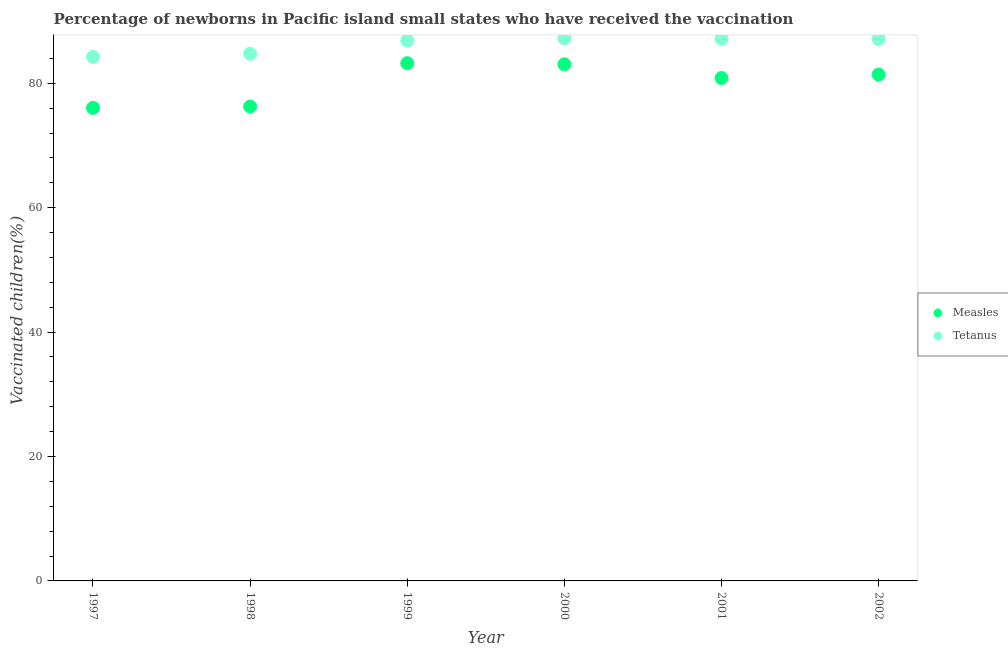What is the percentage of newborns who received vaccination for measles in 1997?
Provide a short and direct response. 76.05. Across all years, what is the maximum percentage of newborns who received vaccination for measles?
Your response must be concise. 83.22. Across all years, what is the minimum percentage of newborns who received vaccination for tetanus?
Your answer should be very brief. 84.24. What is the total percentage of newborns who received vaccination for tetanus in the graph?
Give a very brief answer. 517.33. What is the difference between the percentage of newborns who received vaccination for measles in 2001 and that in 2002?
Offer a terse response. -0.55. What is the difference between the percentage of newborns who received vaccination for tetanus in 2002 and the percentage of newborns who received vaccination for measles in 1998?
Ensure brevity in your answer.  10.85. What is the average percentage of newborns who received vaccination for tetanus per year?
Provide a short and direct response. 86.22. In the year 2000, what is the difference between the percentage of newborns who received vaccination for tetanus and percentage of newborns who received vaccination for measles?
Your answer should be very brief. 4.17. What is the ratio of the percentage of newborns who received vaccination for tetanus in 1999 to that in 2000?
Ensure brevity in your answer.  1. What is the difference between the highest and the second highest percentage of newborns who received vaccination for tetanus?
Give a very brief answer. 0.06. What is the difference between the highest and the lowest percentage of newborns who received vaccination for tetanus?
Keep it short and to the point. 2.97. In how many years, is the percentage of newborns who received vaccination for measles greater than the average percentage of newborns who received vaccination for measles taken over all years?
Provide a short and direct response. 4. Is the sum of the percentage of newborns who received vaccination for measles in 2001 and 2002 greater than the maximum percentage of newborns who received vaccination for tetanus across all years?
Offer a terse response. Yes. How many years are there in the graph?
Offer a terse response. 6. What is the difference between two consecutive major ticks on the Y-axis?
Offer a terse response. 20. Are the values on the major ticks of Y-axis written in scientific E-notation?
Provide a short and direct response. No. Does the graph contain any zero values?
Ensure brevity in your answer.  No. Does the graph contain grids?
Your response must be concise. No. Where does the legend appear in the graph?
Your answer should be very brief. Center right. How many legend labels are there?
Your response must be concise. 2. How are the legend labels stacked?
Your answer should be very brief. Vertical. What is the title of the graph?
Keep it short and to the point. Percentage of newborns in Pacific island small states who have received the vaccination. What is the label or title of the X-axis?
Your answer should be compact. Year. What is the label or title of the Y-axis?
Make the answer very short. Vaccinated children(%)
. What is the Vaccinated children(%)
 of Measles in 1997?
Give a very brief answer. 76.05. What is the Vaccinated children(%)
 of Tetanus in 1997?
Your answer should be very brief. 84.24. What is the Vaccinated children(%)
 of Measles in 1998?
Offer a terse response. 76.25. What is the Vaccinated children(%)
 in Tetanus in 1998?
Make the answer very short. 84.74. What is the Vaccinated children(%)
 in Measles in 1999?
Keep it short and to the point. 83.22. What is the Vaccinated children(%)
 in Tetanus in 1999?
Ensure brevity in your answer.  86.87. What is the Vaccinated children(%)
 of Measles in 2000?
Offer a terse response. 83.05. What is the Vaccinated children(%)
 of Tetanus in 2000?
Offer a very short reply. 87.22. What is the Vaccinated children(%)
 of Measles in 2001?
Offer a terse response. 80.84. What is the Vaccinated children(%)
 of Tetanus in 2001?
Provide a short and direct response. 87.16. What is the Vaccinated children(%)
 in Measles in 2002?
Make the answer very short. 81.39. What is the Vaccinated children(%)
 of Tetanus in 2002?
Your response must be concise. 87.1. Across all years, what is the maximum Vaccinated children(%)
 of Measles?
Provide a succinct answer. 83.22. Across all years, what is the maximum Vaccinated children(%)
 of Tetanus?
Keep it short and to the point. 87.22. Across all years, what is the minimum Vaccinated children(%)
 in Measles?
Your answer should be very brief. 76.05. Across all years, what is the minimum Vaccinated children(%)
 of Tetanus?
Offer a terse response. 84.24. What is the total Vaccinated children(%)
 in Measles in the graph?
Make the answer very short. 480.8. What is the total Vaccinated children(%)
 of Tetanus in the graph?
Your answer should be very brief. 517.33. What is the difference between the Vaccinated children(%)
 in Measles in 1997 and that in 1998?
Give a very brief answer. -0.21. What is the difference between the Vaccinated children(%)
 of Tetanus in 1997 and that in 1998?
Provide a short and direct response. -0.5. What is the difference between the Vaccinated children(%)
 of Measles in 1997 and that in 1999?
Provide a short and direct response. -7.17. What is the difference between the Vaccinated children(%)
 in Tetanus in 1997 and that in 1999?
Ensure brevity in your answer.  -2.63. What is the difference between the Vaccinated children(%)
 in Measles in 1997 and that in 2000?
Offer a very short reply. -7. What is the difference between the Vaccinated children(%)
 of Tetanus in 1997 and that in 2000?
Provide a short and direct response. -2.97. What is the difference between the Vaccinated children(%)
 in Measles in 1997 and that in 2001?
Provide a succinct answer. -4.8. What is the difference between the Vaccinated children(%)
 in Tetanus in 1997 and that in 2001?
Your answer should be very brief. -2.92. What is the difference between the Vaccinated children(%)
 of Measles in 1997 and that in 2002?
Offer a very short reply. -5.34. What is the difference between the Vaccinated children(%)
 of Tetanus in 1997 and that in 2002?
Provide a short and direct response. -2.86. What is the difference between the Vaccinated children(%)
 of Measles in 1998 and that in 1999?
Provide a succinct answer. -6.96. What is the difference between the Vaccinated children(%)
 of Tetanus in 1998 and that in 1999?
Keep it short and to the point. -2.13. What is the difference between the Vaccinated children(%)
 in Measles in 1998 and that in 2000?
Provide a short and direct response. -6.79. What is the difference between the Vaccinated children(%)
 in Tetanus in 1998 and that in 2000?
Your answer should be very brief. -2.47. What is the difference between the Vaccinated children(%)
 in Measles in 1998 and that in 2001?
Provide a succinct answer. -4.59. What is the difference between the Vaccinated children(%)
 in Tetanus in 1998 and that in 2001?
Your answer should be compact. -2.42. What is the difference between the Vaccinated children(%)
 in Measles in 1998 and that in 2002?
Provide a short and direct response. -5.14. What is the difference between the Vaccinated children(%)
 of Tetanus in 1998 and that in 2002?
Provide a succinct answer. -2.36. What is the difference between the Vaccinated children(%)
 in Measles in 1999 and that in 2000?
Keep it short and to the point. 0.17. What is the difference between the Vaccinated children(%)
 in Tetanus in 1999 and that in 2000?
Offer a terse response. -0.35. What is the difference between the Vaccinated children(%)
 in Measles in 1999 and that in 2001?
Make the answer very short. 2.38. What is the difference between the Vaccinated children(%)
 in Tetanus in 1999 and that in 2001?
Give a very brief answer. -0.29. What is the difference between the Vaccinated children(%)
 of Measles in 1999 and that in 2002?
Ensure brevity in your answer.  1.83. What is the difference between the Vaccinated children(%)
 in Tetanus in 1999 and that in 2002?
Make the answer very short. -0.23. What is the difference between the Vaccinated children(%)
 of Measles in 2000 and that in 2001?
Make the answer very short. 2.21. What is the difference between the Vaccinated children(%)
 of Tetanus in 2000 and that in 2001?
Your answer should be compact. 0.06. What is the difference between the Vaccinated children(%)
 in Measles in 2000 and that in 2002?
Offer a very short reply. 1.66. What is the difference between the Vaccinated children(%)
 in Tetanus in 2000 and that in 2002?
Your answer should be compact. 0.11. What is the difference between the Vaccinated children(%)
 of Measles in 2001 and that in 2002?
Offer a terse response. -0.55. What is the difference between the Vaccinated children(%)
 in Tetanus in 2001 and that in 2002?
Offer a very short reply. 0.06. What is the difference between the Vaccinated children(%)
 in Measles in 1997 and the Vaccinated children(%)
 in Tetanus in 1998?
Provide a succinct answer. -8.7. What is the difference between the Vaccinated children(%)
 of Measles in 1997 and the Vaccinated children(%)
 of Tetanus in 1999?
Ensure brevity in your answer.  -10.83. What is the difference between the Vaccinated children(%)
 in Measles in 1997 and the Vaccinated children(%)
 in Tetanus in 2000?
Ensure brevity in your answer.  -11.17. What is the difference between the Vaccinated children(%)
 of Measles in 1997 and the Vaccinated children(%)
 of Tetanus in 2001?
Keep it short and to the point. -11.11. What is the difference between the Vaccinated children(%)
 of Measles in 1997 and the Vaccinated children(%)
 of Tetanus in 2002?
Give a very brief answer. -11.06. What is the difference between the Vaccinated children(%)
 of Measles in 1998 and the Vaccinated children(%)
 of Tetanus in 1999?
Your answer should be very brief. -10.62. What is the difference between the Vaccinated children(%)
 of Measles in 1998 and the Vaccinated children(%)
 of Tetanus in 2000?
Provide a short and direct response. -10.96. What is the difference between the Vaccinated children(%)
 of Measles in 1998 and the Vaccinated children(%)
 of Tetanus in 2001?
Keep it short and to the point. -10.91. What is the difference between the Vaccinated children(%)
 of Measles in 1998 and the Vaccinated children(%)
 of Tetanus in 2002?
Make the answer very short. -10.85. What is the difference between the Vaccinated children(%)
 in Measles in 1999 and the Vaccinated children(%)
 in Tetanus in 2000?
Provide a succinct answer. -4. What is the difference between the Vaccinated children(%)
 in Measles in 1999 and the Vaccinated children(%)
 in Tetanus in 2001?
Provide a short and direct response. -3.94. What is the difference between the Vaccinated children(%)
 of Measles in 1999 and the Vaccinated children(%)
 of Tetanus in 2002?
Your response must be concise. -3.88. What is the difference between the Vaccinated children(%)
 in Measles in 2000 and the Vaccinated children(%)
 in Tetanus in 2001?
Give a very brief answer. -4.11. What is the difference between the Vaccinated children(%)
 of Measles in 2000 and the Vaccinated children(%)
 of Tetanus in 2002?
Offer a very short reply. -4.05. What is the difference between the Vaccinated children(%)
 of Measles in 2001 and the Vaccinated children(%)
 of Tetanus in 2002?
Your answer should be very brief. -6.26. What is the average Vaccinated children(%)
 in Measles per year?
Keep it short and to the point. 80.13. What is the average Vaccinated children(%)
 in Tetanus per year?
Provide a short and direct response. 86.22. In the year 1997, what is the difference between the Vaccinated children(%)
 of Measles and Vaccinated children(%)
 of Tetanus?
Provide a short and direct response. -8.2. In the year 1998, what is the difference between the Vaccinated children(%)
 of Measles and Vaccinated children(%)
 of Tetanus?
Your response must be concise. -8.49. In the year 1999, what is the difference between the Vaccinated children(%)
 of Measles and Vaccinated children(%)
 of Tetanus?
Your answer should be very brief. -3.65. In the year 2000, what is the difference between the Vaccinated children(%)
 of Measles and Vaccinated children(%)
 of Tetanus?
Keep it short and to the point. -4.17. In the year 2001, what is the difference between the Vaccinated children(%)
 of Measles and Vaccinated children(%)
 of Tetanus?
Keep it short and to the point. -6.32. In the year 2002, what is the difference between the Vaccinated children(%)
 in Measles and Vaccinated children(%)
 in Tetanus?
Offer a terse response. -5.71. What is the ratio of the Vaccinated children(%)
 in Measles in 1997 to that in 1998?
Provide a short and direct response. 1. What is the ratio of the Vaccinated children(%)
 of Tetanus in 1997 to that in 1998?
Make the answer very short. 0.99. What is the ratio of the Vaccinated children(%)
 in Measles in 1997 to that in 1999?
Keep it short and to the point. 0.91. What is the ratio of the Vaccinated children(%)
 of Tetanus in 1997 to that in 1999?
Ensure brevity in your answer.  0.97. What is the ratio of the Vaccinated children(%)
 in Measles in 1997 to that in 2000?
Offer a very short reply. 0.92. What is the ratio of the Vaccinated children(%)
 of Tetanus in 1997 to that in 2000?
Ensure brevity in your answer.  0.97. What is the ratio of the Vaccinated children(%)
 in Measles in 1997 to that in 2001?
Offer a terse response. 0.94. What is the ratio of the Vaccinated children(%)
 in Tetanus in 1997 to that in 2001?
Your response must be concise. 0.97. What is the ratio of the Vaccinated children(%)
 of Measles in 1997 to that in 2002?
Your answer should be very brief. 0.93. What is the ratio of the Vaccinated children(%)
 of Tetanus in 1997 to that in 2002?
Offer a very short reply. 0.97. What is the ratio of the Vaccinated children(%)
 in Measles in 1998 to that in 1999?
Offer a very short reply. 0.92. What is the ratio of the Vaccinated children(%)
 in Tetanus in 1998 to that in 1999?
Give a very brief answer. 0.98. What is the ratio of the Vaccinated children(%)
 of Measles in 1998 to that in 2000?
Provide a succinct answer. 0.92. What is the ratio of the Vaccinated children(%)
 in Tetanus in 1998 to that in 2000?
Your answer should be compact. 0.97. What is the ratio of the Vaccinated children(%)
 in Measles in 1998 to that in 2001?
Give a very brief answer. 0.94. What is the ratio of the Vaccinated children(%)
 of Tetanus in 1998 to that in 2001?
Provide a short and direct response. 0.97. What is the ratio of the Vaccinated children(%)
 of Measles in 1998 to that in 2002?
Make the answer very short. 0.94. What is the ratio of the Vaccinated children(%)
 of Tetanus in 1998 to that in 2002?
Your answer should be compact. 0.97. What is the ratio of the Vaccinated children(%)
 in Measles in 1999 to that in 2000?
Keep it short and to the point. 1. What is the ratio of the Vaccinated children(%)
 of Measles in 1999 to that in 2001?
Ensure brevity in your answer.  1.03. What is the ratio of the Vaccinated children(%)
 of Measles in 1999 to that in 2002?
Ensure brevity in your answer.  1.02. What is the ratio of the Vaccinated children(%)
 of Tetanus in 1999 to that in 2002?
Offer a terse response. 1. What is the ratio of the Vaccinated children(%)
 in Measles in 2000 to that in 2001?
Keep it short and to the point. 1.03. What is the ratio of the Vaccinated children(%)
 of Tetanus in 2000 to that in 2001?
Your answer should be very brief. 1. What is the ratio of the Vaccinated children(%)
 of Measles in 2000 to that in 2002?
Your answer should be very brief. 1.02. What is the ratio of the Vaccinated children(%)
 of Measles in 2001 to that in 2002?
Provide a short and direct response. 0.99. What is the ratio of the Vaccinated children(%)
 of Tetanus in 2001 to that in 2002?
Provide a succinct answer. 1. What is the difference between the highest and the second highest Vaccinated children(%)
 in Measles?
Offer a terse response. 0.17. What is the difference between the highest and the second highest Vaccinated children(%)
 in Tetanus?
Your answer should be compact. 0.06. What is the difference between the highest and the lowest Vaccinated children(%)
 of Measles?
Provide a succinct answer. 7.17. What is the difference between the highest and the lowest Vaccinated children(%)
 in Tetanus?
Offer a terse response. 2.97. 